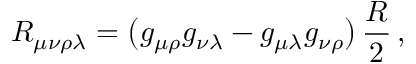Convert formula to latex. <formula><loc_0><loc_0><loc_500><loc_500>R _ { \mu \nu \rho \lambda } = \left ( g _ { \mu \rho } g _ { \nu \lambda } - g _ { \mu \lambda } g _ { \nu \rho } \right ) \, \frac { R } { 2 } \, ,</formula> 